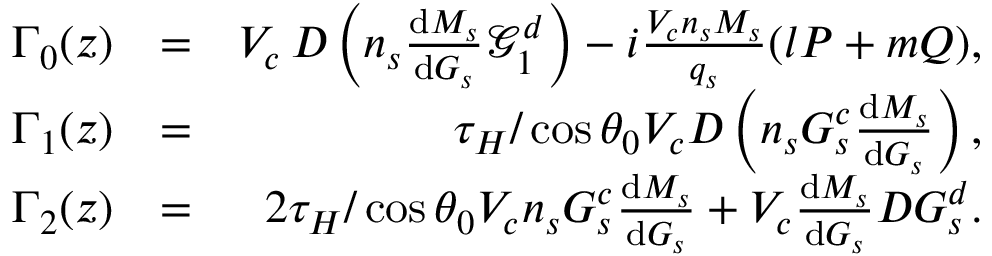<formula> <loc_0><loc_0><loc_500><loc_500>\begin{array} { r l r } { \Gamma _ { 0 } ( z ) } & { = } & { V _ { c } \, D \left ( n _ { s } \frac { { d } M _ { s } } { { d } G _ { s } } \mathcal { G } _ { 1 } ^ { d } \right ) - i \frac { V _ { c } n _ { s } M _ { s } } { q _ { s } } ( l P + m Q ) , } \\ { \Gamma _ { 1 } ( z ) } & { = } & { \tau _ { H } / \cos { \theta _ { 0 } } V _ { c } D \left ( n _ { s } G _ { s } ^ { c } \frac { { d } M _ { s } } { { d } G _ { s } } \right ) , } \\ { \Gamma _ { 2 } ( z ) } & { = } & { 2 \tau _ { H } / \cos { \theta _ { 0 } } V _ { c } n _ { s } G _ { s } ^ { c } \frac { { d } M _ { s } } { { d } G _ { s } } + V _ { c } \frac { { d } M _ { s } } { { d } G _ { s } } D G _ { s } ^ { d } . } \end{array}</formula> 